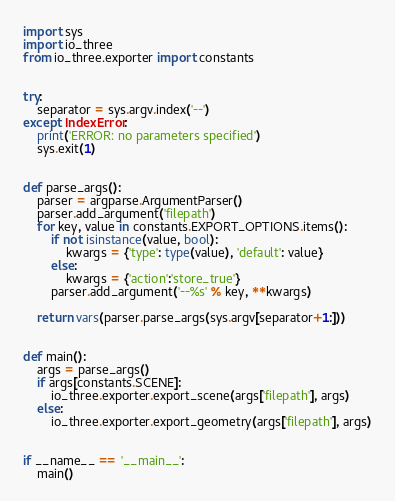Convert code to text. <code><loc_0><loc_0><loc_500><loc_500><_Python_>import sys
import io_three
from io_three.exporter import constants


try:
    separator = sys.argv.index('--')
except IndexError:
    print('ERROR: no parameters specified')
    sys.exit(1)


def parse_args():
    parser = argparse.ArgumentParser()
    parser.add_argument('filepath')
    for key, value in constants.EXPORT_OPTIONS.items():
        if not isinstance(value, bool):
            kwargs = {'type': type(value), 'default': value}
        else:
            kwargs = {'action':'store_true'}
        parser.add_argument('--%s' % key, **kwargs)

    return vars(parser.parse_args(sys.argv[separator+1:]))


def main():
    args = parse_args()
    if args[constants.SCENE]:
        io_three.exporter.export_scene(args['filepath'], args)
    else:
        io_three.exporter.export_geometry(args['filepath'], args)


if __name__ == '__main__':
    main()
</code> 